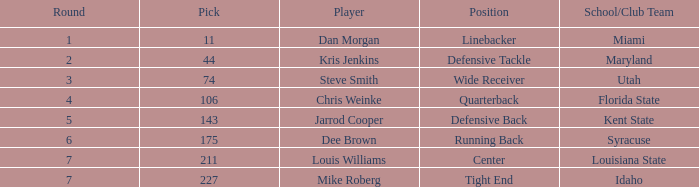Where did steve smith go to school? Utah. 